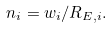Convert formula to latex. <formula><loc_0><loc_0><loc_500><loc_500>n _ { i } = w _ { i } / R _ { E , i } .</formula> 